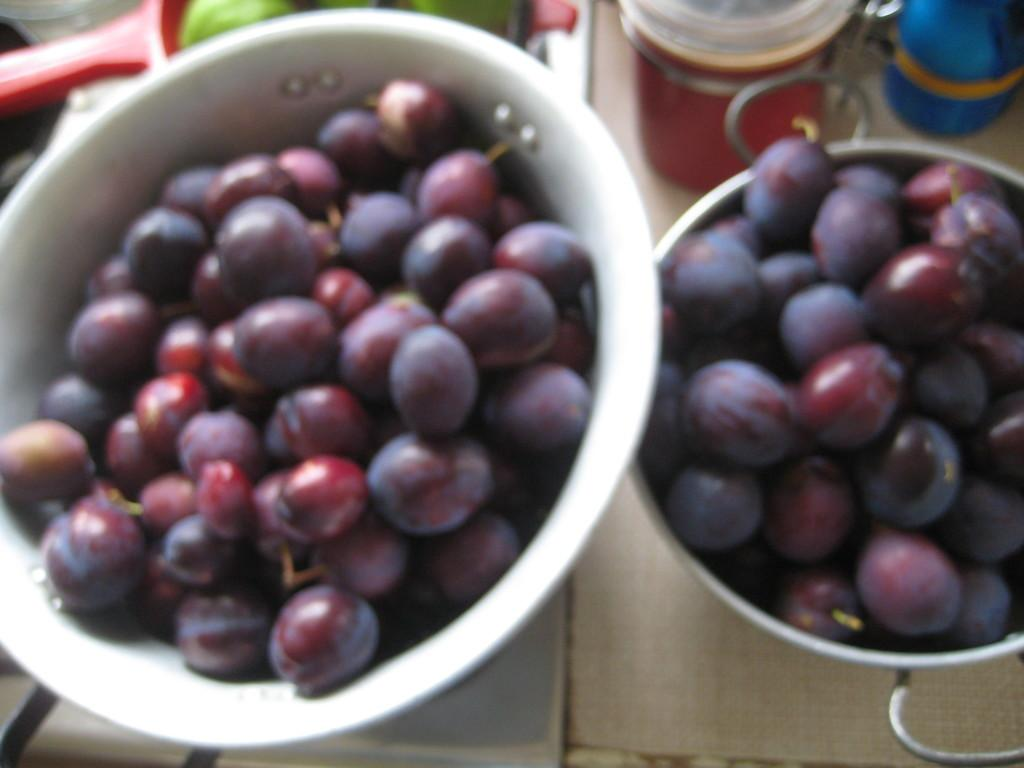What type of fruit is present in the image? There are grapes on bowls in the image. Can you describe any other objects or elements in the image? There are other objects in the background of the image, but their specific details are not mentioned in the provided facts. Who is the cast of the movie that is being filmed in the image? There is no mention of a movie or cast in the provided facts, so we cannot answer this question based on the image. 